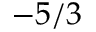Convert formula to latex. <formula><loc_0><loc_0><loc_500><loc_500>- 5 / 3</formula> 